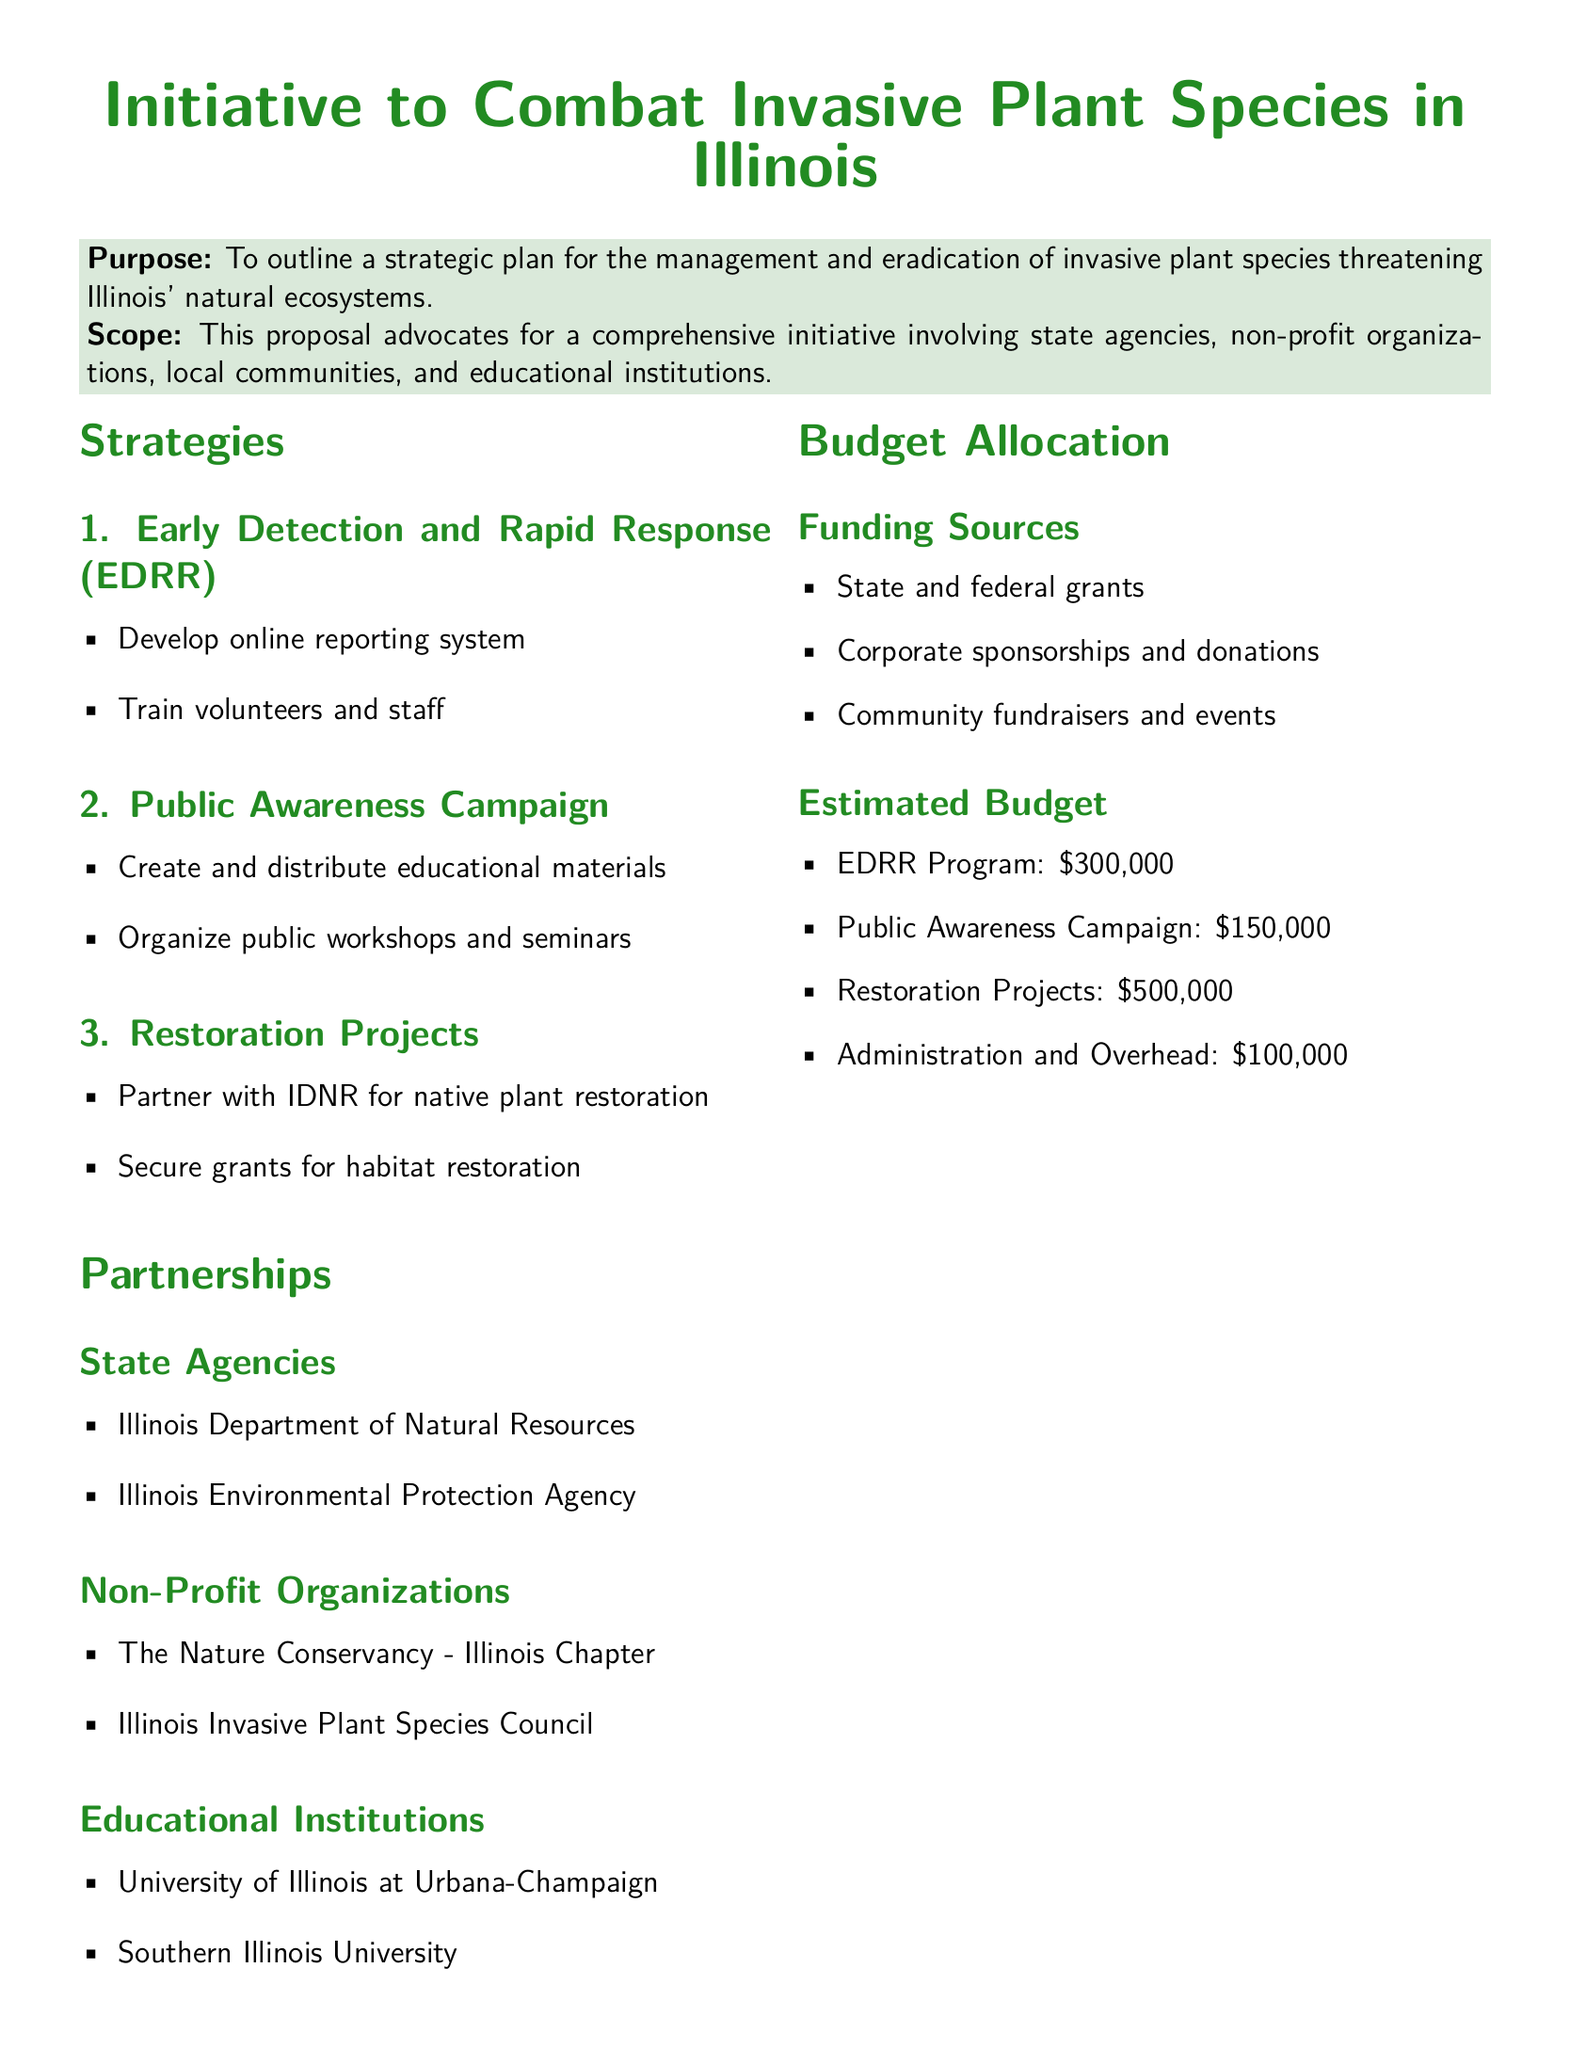What is the main purpose of the initiative? The purpose is explicitly stated in the document as "To outline a strategic plan for the management and eradication of invasive plant species threatening Illinois' natural ecosystems."
Answer: To outline a strategic plan for the management and eradication of invasive plant species threatening Illinois' natural ecosystems Which organization is a partner in the restoration projects? The document lists "Illinois Department of Natural Resources" as a partner for native plant restoration within the Restoration Projects section.
Answer: Illinois Department of Natural Resources What is the estimated budget for the EDRR Program? The budget section provides a specific figure for the EDRR Program as "$300,000."
Answer: $300,000 What type of campaign is mentioned under Strategies? The document mentions a "Public Awareness Campaign" as part of its strategies to combat invasive species.
Answer: Public Awareness Campaign How many educational institutions are listed as partners? The document lists "two" educational institutions under the Partnerships section.
Answer: Two What is one source of funding mentioned in the budget allocation? The document specifies "State and federal grants" as one of the funding sources.
Answer: State and federal grants What does the document urge stakeholders to do? The call to action emphasizes the need for support and participation in the initiative, specifically stating "We urge stakeholders and the community to support and participate in this critical endeavor."
Answer: Support and participate Which color represents the main title of the document? The document explicitly states that the main title is in "forestgreen" color.
Answer: Forestgreen 